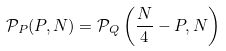Convert formula to latex. <formula><loc_0><loc_0><loc_500><loc_500>\mathcal { P } _ { P } ( P , N ) = \mathcal { P } _ { Q } \left ( \frac { N } { 4 } - P , N \right )</formula> 